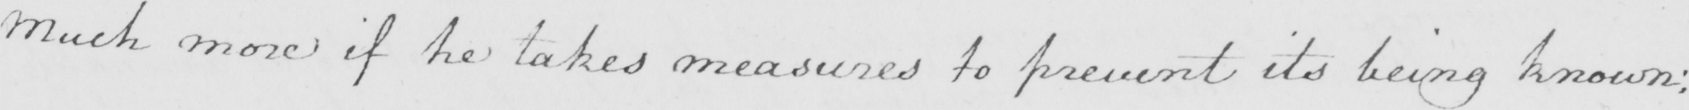Can you tell me what this handwritten text says? Much more if he takes measures to prevent its being known : 